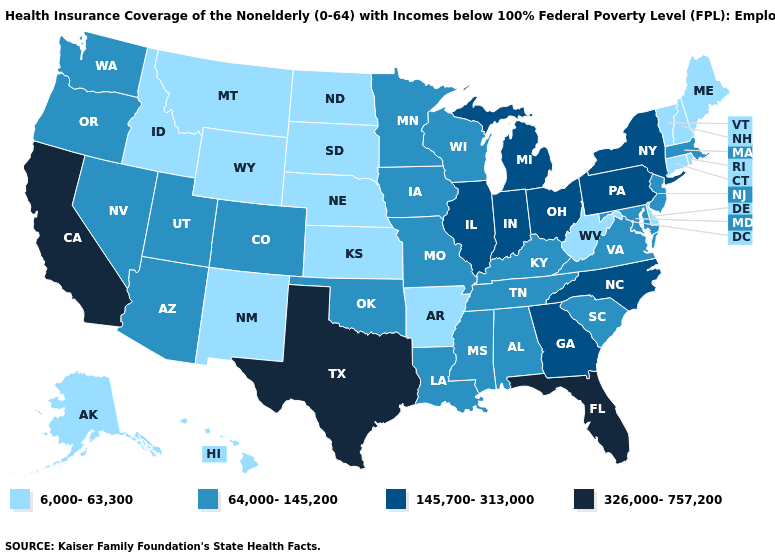What is the lowest value in the West?
Quick response, please. 6,000-63,300. Is the legend a continuous bar?
Give a very brief answer. No. How many symbols are there in the legend?
Quick response, please. 4. Does West Virginia have a lower value than Hawaii?
Write a very short answer. No. What is the value of Rhode Island?
Quick response, please. 6,000-63,300. Does the map have missing data?
Keep it brief. No. What is the value of Virginia?
Quick response, please. 64,000-145,200. Does Louisiana have a higher value than Nebraska?
Concise answer only. Yes. Which states have the highest value in the USA?
Quick response, please. California, Florida, Texas. How many symbols are there in the legend?
Answer briefly. 4. Name the states that have a value in the range 145,700-313,000?
Give a very brief answer. Georgia, Illinois, Indiana, Michigan, New York, North Carolina, Ohio, Pennsylvania. How many symbols are there in the legend?
Answer briefly. 4. Does Rhode Island have the highest value in the Northeast?
Answer briefly. No. What is the highest value in the Northeast ?
Answer briefly. 145,700-313,000. What is the highest value in states that border Nevada?
Quick response, please. 326,000-757,200. 